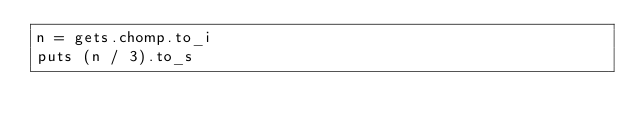Convert code to text. <code><loc_0><loc_0><loc_500><loc_500><_Ruby_>n = gets.chomp.to_i
puts (n / 3).to_s</code> 